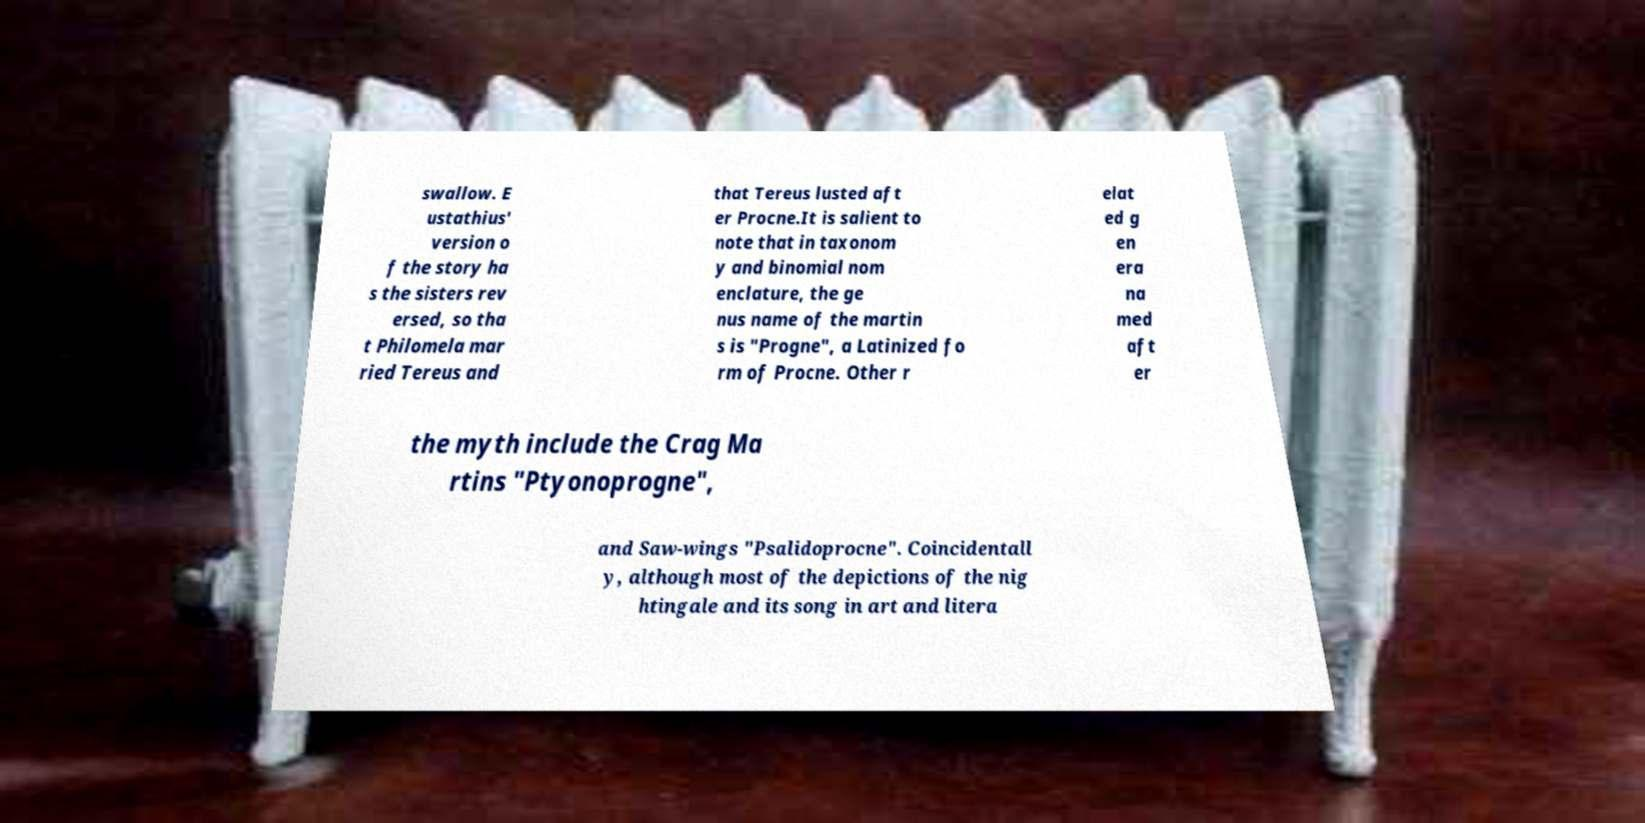For documentation purposes, I need the text within this image transcribed. Could you provide that? swallow. E ustathius' version o f the story ha s the sisters rev ersed, so tha t Philomela mar ried Tereus and that Tereus lusted aft er Procne.It is salient to note that in taxonom y and binomial nom enclature, the ge nus name of the martin s is "Progne", a Latinized fo rm of Procne. Other r elat ed g en era na med aft er the myth include the Crag Ma rtins "Ptyonoprogne", and Saw-wings "Psalidoprocne". Coincidentall y, although most of the depictions of the nig htingale and its song in art and litera 